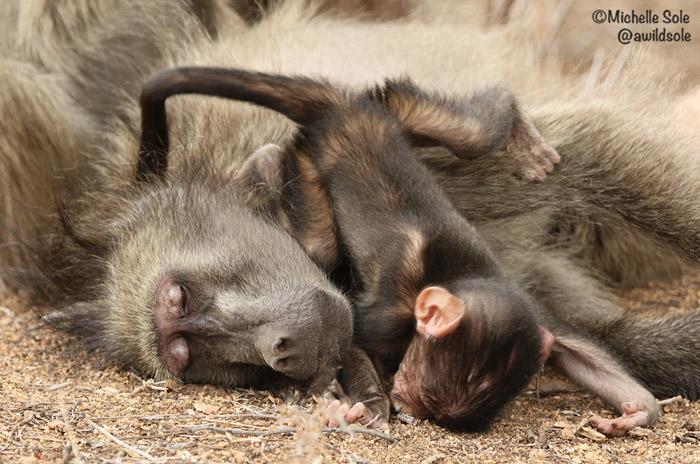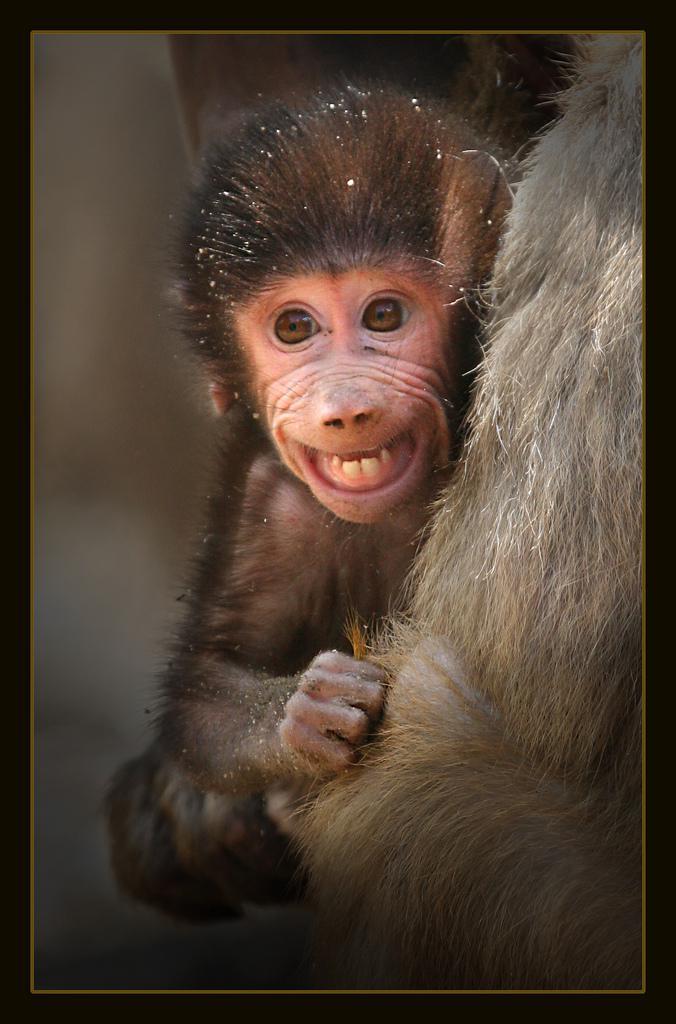The first image is the image on the left, the second image is the image on the right. Analyze the images presented: Is the assertion "There is a baby monkey in each image." valid? Answer yes or no. Yes. The first image is the image on the left, the second image is the image on the right. Examine the images to the left and right. Is the description "All images include a baby baboon, and one image clearly shows a baby baboon with an adult baboon." accurate? Answer yes or no. Yes. 